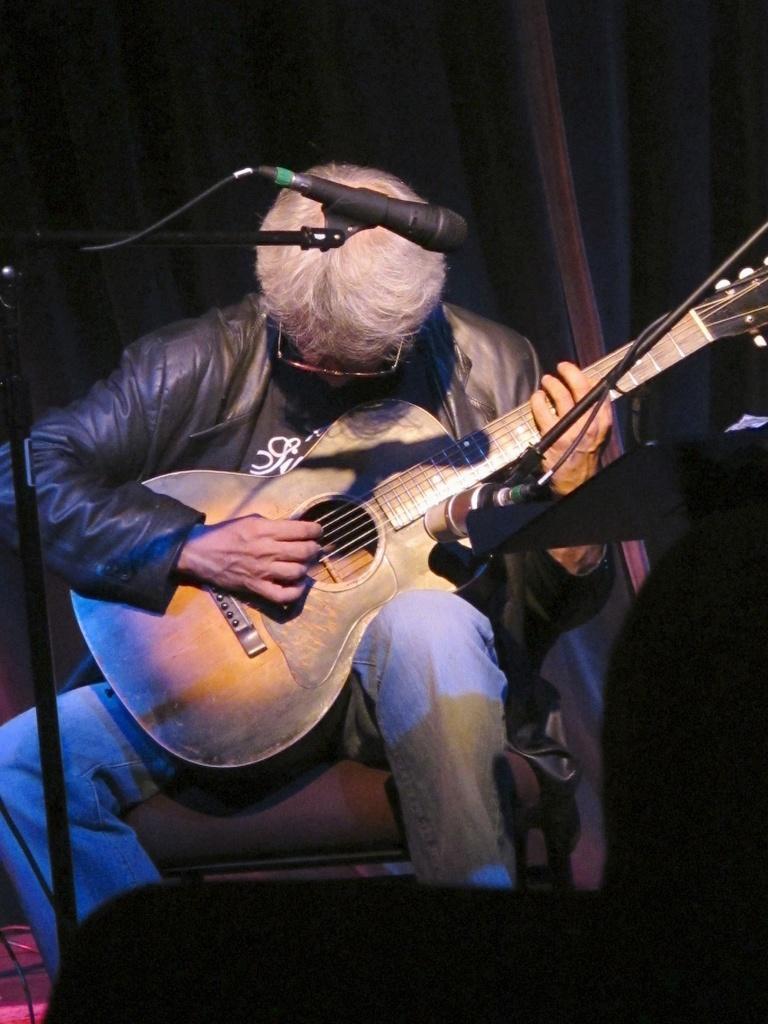In one or two sentences, can you explain what this image depicts? In the image we can see there is a person who is sitting on chair and holding a guitar in his hand. 